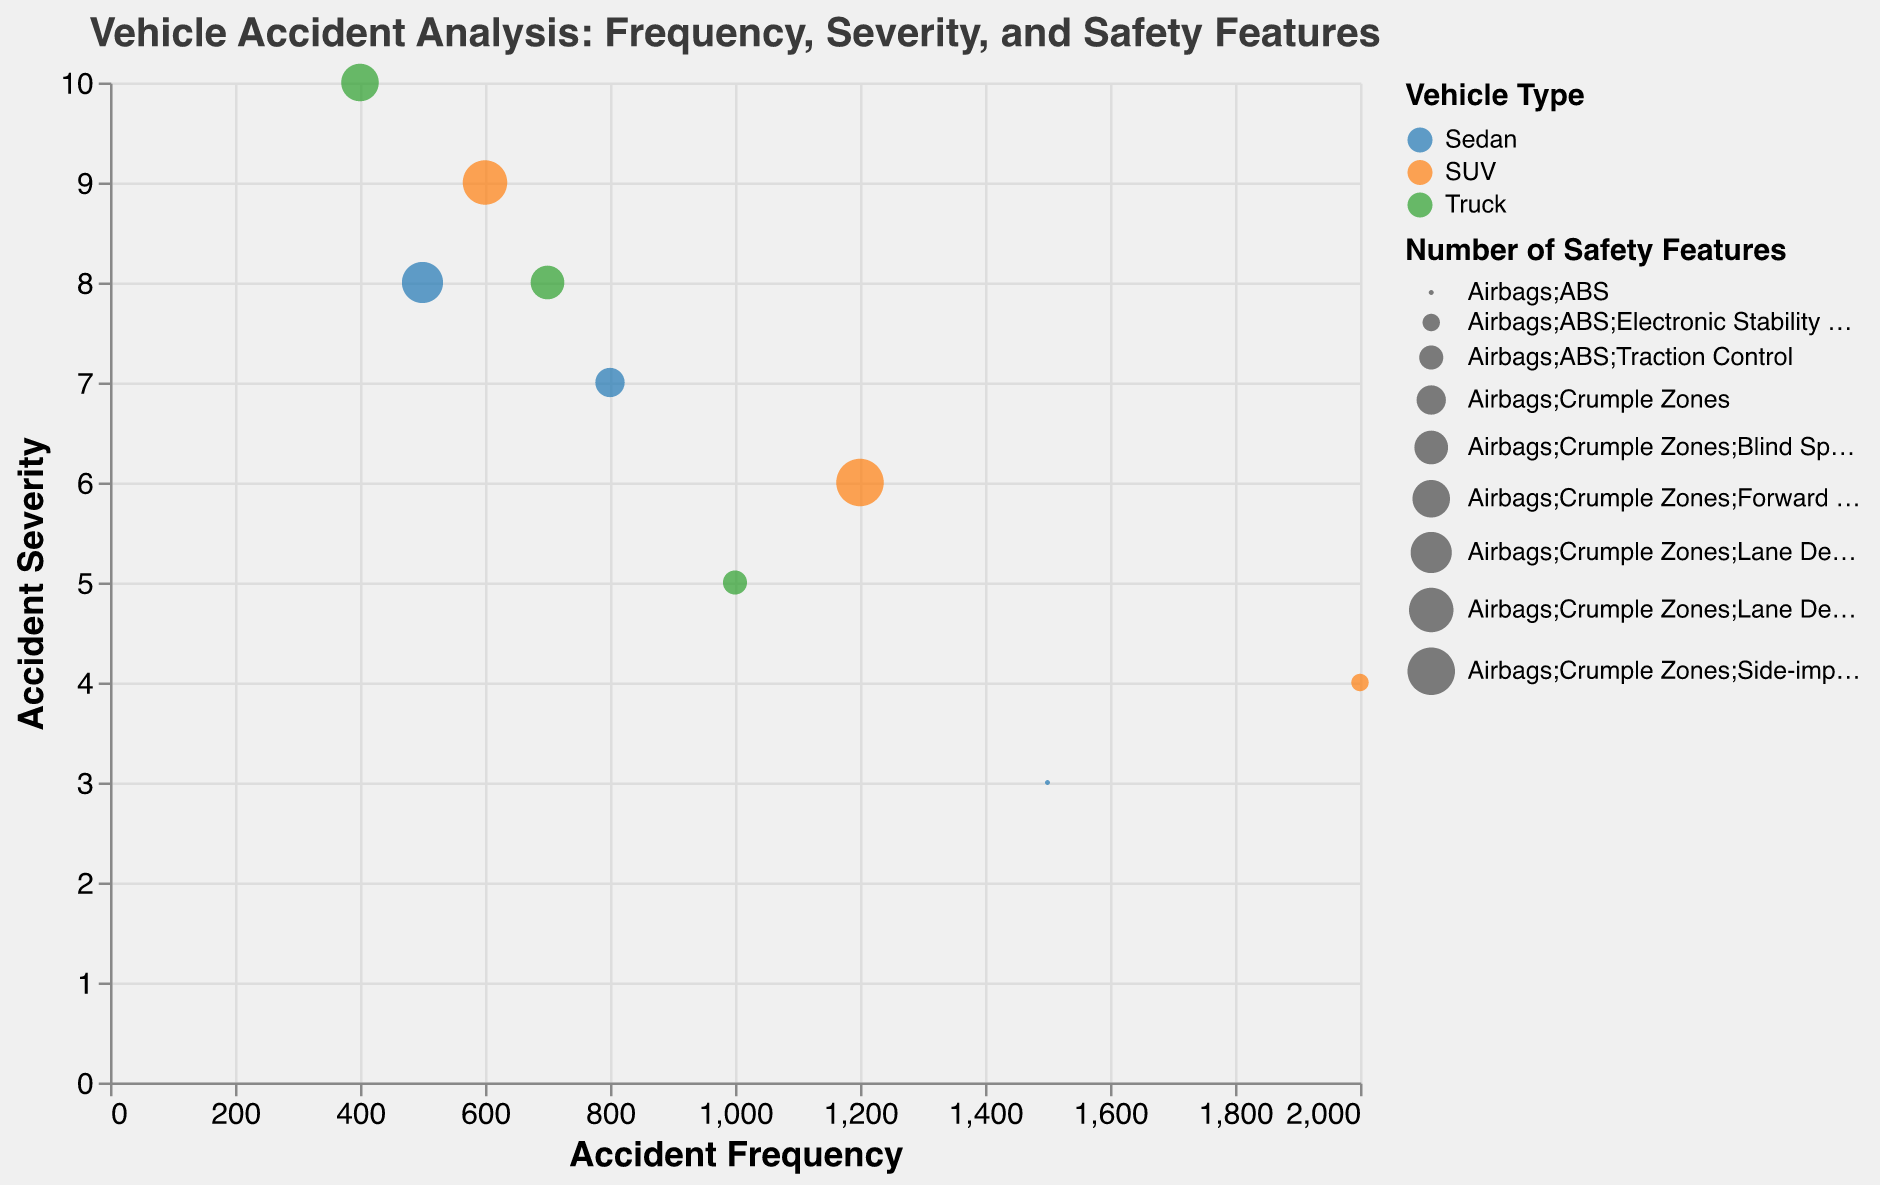What is the highest severity score shown in the figure, and which vehicle type and accident type does it correspond to? The highest severity score in the figure is 10. Observing the figure, we can see that this score corresponds to the "Truck" vehicle type in the "Head-on Collision" category.
Answer: 10, Truck, Head-on Collision How many different types of safety features are listed in the bubble with the highest frequency? The highest frequency is 2000, and the bubble that represents this frequency is for SUVs involved in rear-end collisions. Looking at the tooltip or the bubble size legend, this bubble lists the following safety features: Airbags, ABS, and Electronic Stability Control, totaling 3 safety features.
Answer: 3 Which vehicle type has the lowest frequency of head-on collisions, and what is the frequency? Looking at the figure, we need to find the lowest value under the "Head-on Collision" category. The bubble for "Truck" in the "Head-on Collision" category has the lowest frequency, and the tooltip shows the frequency is 400.
Answer: Truck, 400 Compare the frequency and severity of rear-end collisions for sedans and SUVs. Which vehicle type has a higher severity, and by how much? For rear-end collisions, the severity for sedans is 3, whereas for SUVs, it is 4. Comparing these two values, SUVs have a higher severity by 1 point.
Answer: SUVs, 1 point What’s the total number of head-on collisions across all vehicle types? The head-on collision bubble for sedans shows a frequency of 500, for SUVs is 600, and for trucks is 400. Summing these up gives us 500 + 600 + 400 = 1500 head-on collisions.
Answer: 1500 Among the vehicles with T-bone collisions, which vehicle type has the least severity, and what is the severity score? We look at the T-bone collisions and compare the severity scores: sedans have 7, SUVs have 6, and trucks have 8. Hence, SUVs have the least severity score of 6.
Answer: SUVs, 6 Which vehicle type has the most frequent type of collision, and what feature is common among the safety features included in their respective bubbles? The most frequent type of collision is rear-end for SUVs with a frequency of 2000. Common features among its safety features are Airbags, ABS, and Electronic Stability Control, and comparing safety features of other vehicle types, "Airbags" is the common safety feature.
Answer: SUVs, Airbags Rank the severity of rear-end collisions by vehicle type from highest to lowest. Observing the severity scores for rear-end collisions: SUVs have a severity of 4, trucks have 5, and sedans have 3. Ranking from highest to lowest: Truck (5), SUV (4), Sedan (3).
Answer: Truck, SUV, Sedan 